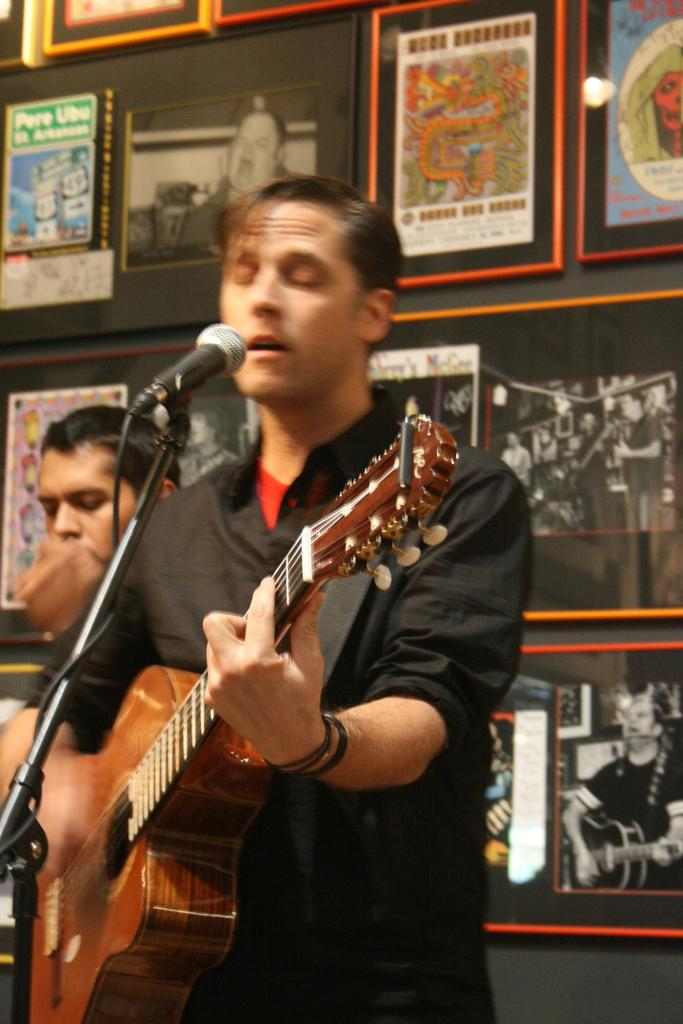What is the man in the image doing? The man is playing a guitar in the image. What object is present that is commonly used for amplifying sound? There is a microphone in the image. What type of jelly can be seen on the guitar strings in the image? There is no jelly present on the guitar strings in the image. How does the mark on the man's forehead relate to the moon in the image? There is no mark on the man's forehead, nor is there any mention of the moon in the image. 